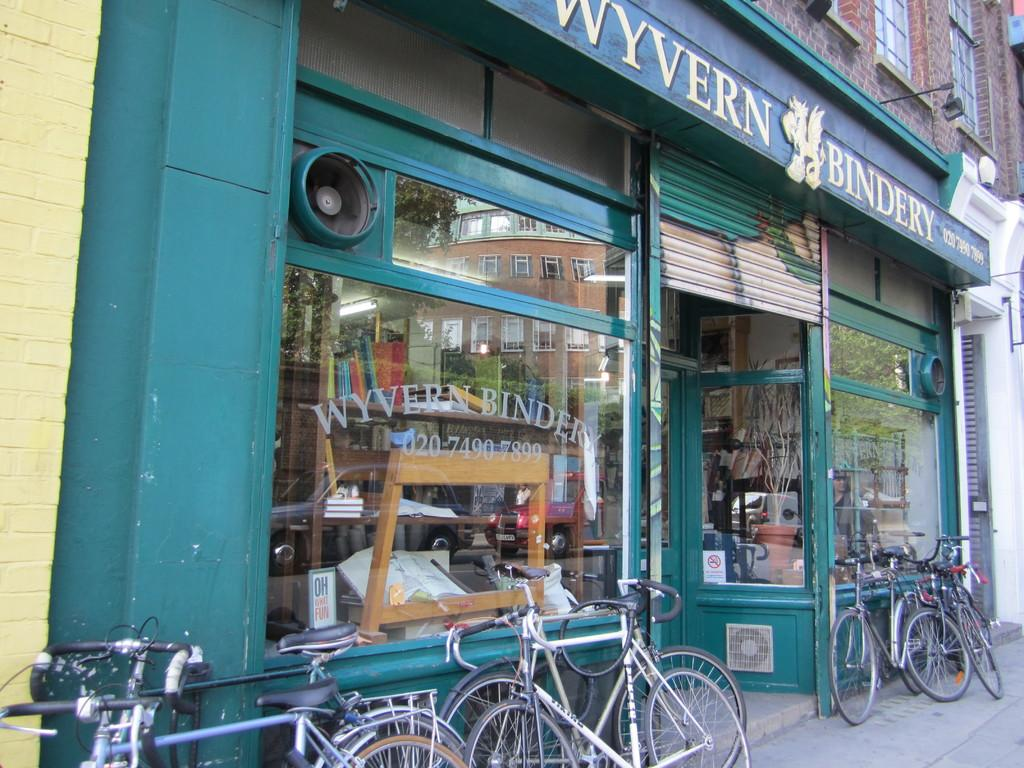<image>
Give a short and clear explanation of the subsequent image. Several bikes are leaning on a green building with a sign saying Wyvern Bindery. 